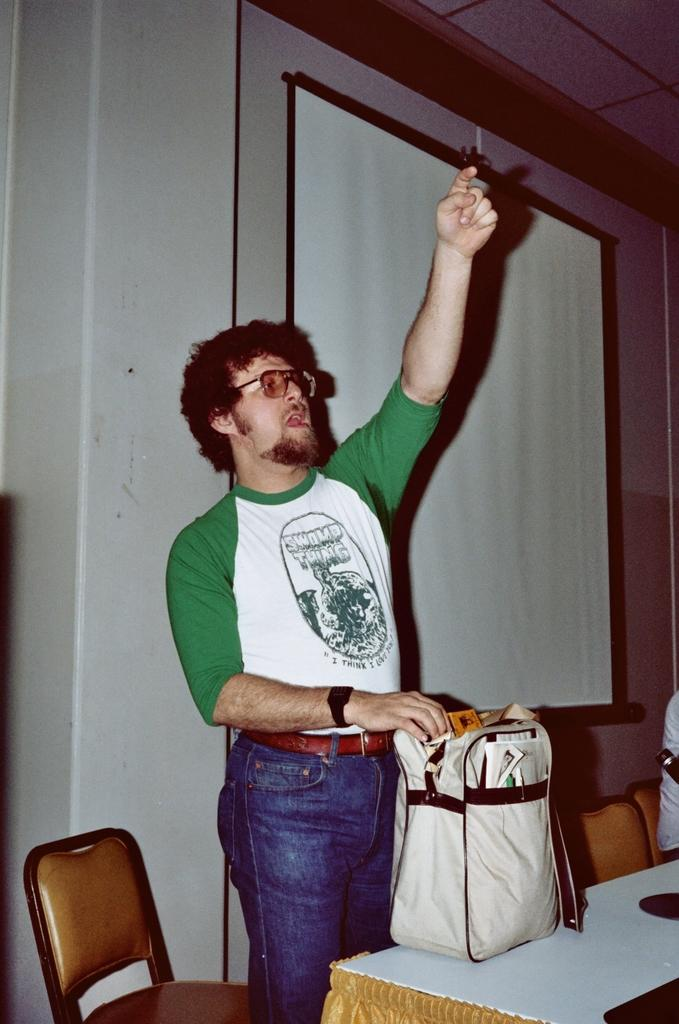What is the man in the image doing? The man is standing in the image. What is the man holding in the image? The man is holding a bag. Where is the man located in relation to other objects in the image? The man is standing near a table. What can be seen in the background of the image? There is a chair, a screen, and a wall in the background of the image. What type of soup is the man eating in the image? There is no soup present in the image; the man is holding a bag and standing near a table. 